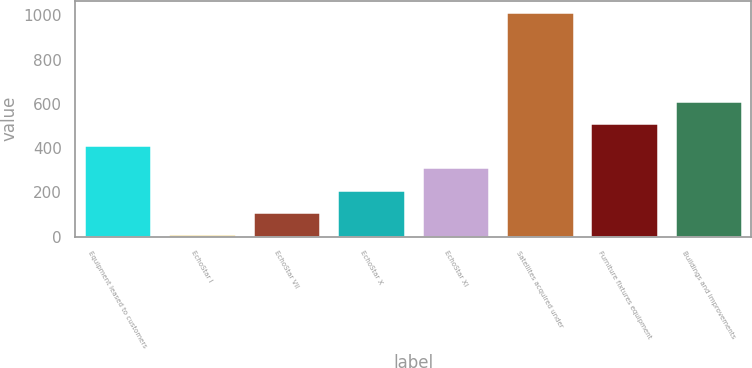<chart> <loc_0><loc_0><loc_500><loc_500><bar_chart><fcel>Equipment leased to customers<fcel>EchoStar I<fcel>EchoStar VII<fcel>EchoStar X<fcel>EchoStar XI<fcel>Satellites acquired under<fcel>Furniture fixtures equipment<fcel>Buildings and improvements<nl><fcel>413.2<fcel>12<fcel>112.3<fcel>212.6<fcel>312.9<fcel>1015<fcel>513.5<fcel>613.8<nl></chart> 